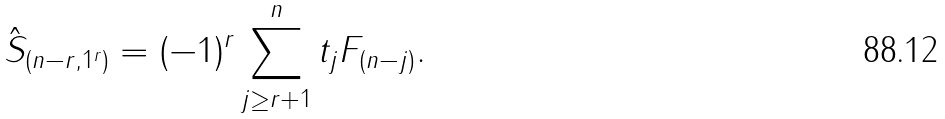Convert formula to latex. <formula><loc_0><loc_0><loc_500><loc_500>\hat { S } _ { ( n - r , 1 ^ { r } ) } = ( - 1 ) ^ { r } \sum _ { j \geq r + 1 } ^ { n } t _ { j } F _ { ( n - j ) } .</formula> 